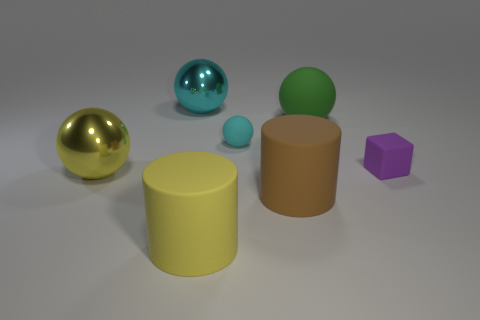Subtract all yellow metal spheres. How many spheres are left? 3 Subtract all green cubes. How many cyan spheres are left? 2 Add 2 brown rubber cylinders. How many objects exist? 9 Subtract all yellow spheres. How many spheres are left? 3 Subtract all cylinders. How many objects are left? 5 Subtract all cyan blocks. Subtract all yellow cylinders. How many blocks are left? 1 Add 7 large cyan balls. How many large cyan balls are left? 8 Add 4 brown matte cylinders. How many brown matte cylinders exist? 5 Subtract 1 green spheres. How many objects are left? 6 Subtract all tiny cyan things. Subtract all large brown rubber cylinders. How many objects are left? 5 